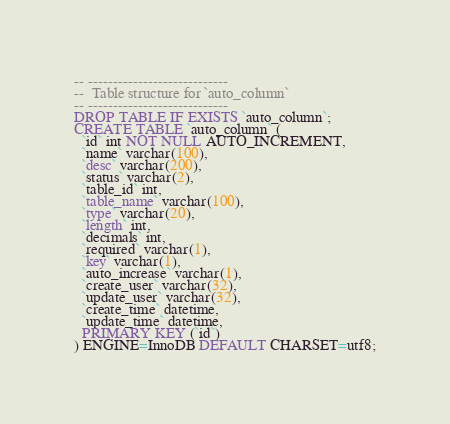Convert code to text. <code><loc_0><loc_0><loc_500><loc_500><_SQL_>
-- ----------------------------
--  Table structure for `auto_column`
-- ----------------------------
DROP TABLE IF EXISTS `auto_column`;
CREATE TABLE `auto_column` (
  `id` int NOT NULL AUTO_INCREMENT,
  `name` varchar(100),
  `desc` varchar(200),
  `status` varchar(2),
  `table_id` int,
  `table_name` varchar(100),
  `type` varchar(20),
  `length` int,
  `decimals` int,
  `required` varchar(1),
  `key` varchar(1),
  `auto_increase` varchar(1),
  `create_user` varchar(32),
  `update_user` varchar(32),
  `create_time` datetime,
  `update_time` datetime,
  PRIMARY KEY (`id`)
) ENGINE=InnoDB DEFAULT CHARSET=utf8;</code> 